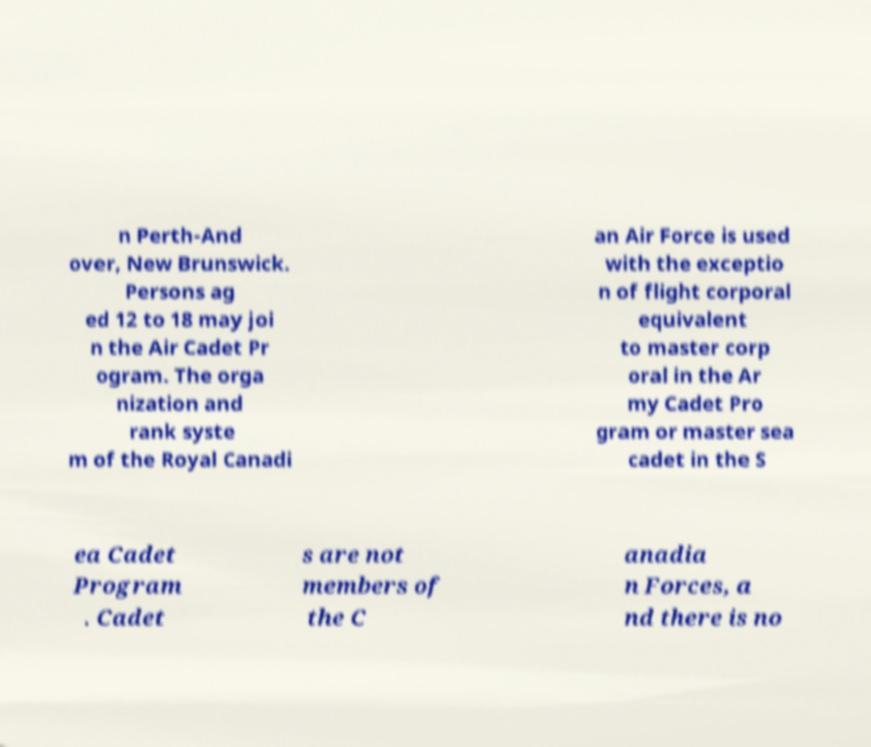Can you read and provide the text displayed in the image?This photo seems to have some interesting text. Can you extract and type it out for me? n Perth-And over, New Brunswick. Persons ag ed 12 to 18 may joi n the Air Cadet Pr ogram. The orga nization and rank syste m of the Royal Canadi an Air Force is used with the exceptio n of flight corporal equivalent to master corp oral in the Ar my Cadet Pro gram or master sea cadet in the S ea Cadet Program . Cadet s are not members of the C anadia n Forces, a nd there is no 